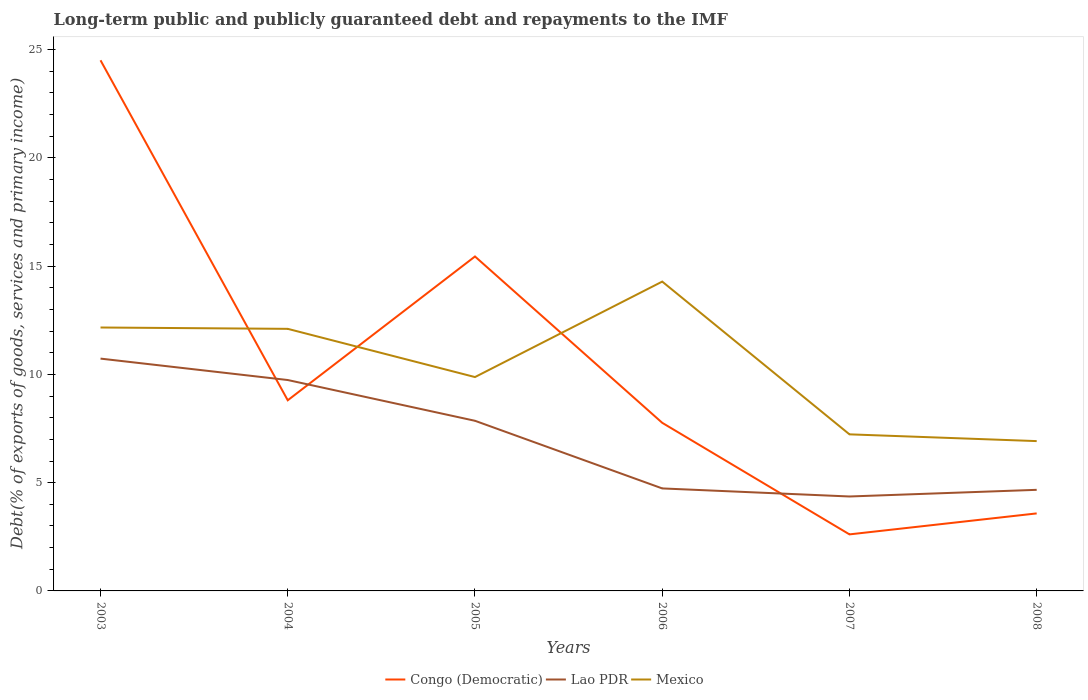Across all years, what is the maximum debt and repayments in Mexico?
Ensure brevity in your answer.  6.92. What is the total debt and repayments in Mexico in the graph?
Your answer should be compact. 5.25. What is the difference between the highest and the second highest debt and repayments in Mexico?
Your response must be concise. 7.37. Is the debt and repayments in Lao PDR strictly greater than the debt and repayments in Mexico over the years?
Ensure brevity in your answer.  Yes. How many lines are there?
Your answer should be very brief. 3. Does the graph contain grids?
Your answer should be very brief. No. How many legend labels are there?
Your answer should be compact. 3. How are the legend labels stacked?
Provide a short and direct response. Horizontal. What is the title of the graph?
Give a very brief answer. Long-term public and publicly guaranteed debt and repayments to the IMF. Does "Sudan" appear as one of the legend labels in the graph?
Offer a very short reply. No. What is the label or title of the X-axis?
Offer a very short reply. Years. What is the label or title of the Y-axis?
Give a very brief answer. Debt(% of exports of goods, services and primary income). What is the Debt(% of exports of goods, services and primary income) in Congo (Democratic) in 2003?
Keep it short and to the point. 24.51. What is the Debt(% of exports of goods, services and primary income) in Lao PDR in 2003?
Your answer should be very brief. 10.73. What is the Debt(% of exports of goods, services and primary income) in Mexico in 2003?
Offer a very short reply. 12.17. What is the Debt(% of exports of goods, services and primary income) in Congo (Democratic) in 2004?
Make the answer very short. 8.8. What is the Debt(% of exports of goods, services and primary income) in Lao PDR in 2004?
Your answer should be very brief. 9.74. What is the Debt(% of exports of goods, services and primary income) in Mexico in 2004?
Your answer should be compact. 12.1. What is the Debt(% of exports of goods, services and primary income) of Congo (Democratic) in 2005?
Make the answer very short. 15.45. What is the Debt(% of exports of goods, services and primary income) in Lao PDR in 2005?
Make the answer very short. 7.86. What is the Debt(% of exports of goods, services and primary income) in Mexico in 2005?
Offer a terse response. 9.88. What is the Debt(% of exports of goods, services and primary income) in Congo (Democratic) in 2006?
Provide a short and direct response. 7.76. What is the Debt(% of exports of goods, services and primary income) in Lao PDR in 2006?
Ensure brevity in your answer.  4.73. What is the Debt(% of exports of goods, services and primary income) of Mexico in 2006?
Make the answer very short. 14.29. What is the Debt(% of exports of goods, services and primary income) of Congo (Democratic) in 2007?
Make the answer very short. 2.61. What is the Debt(% of exports of goods, services and primary income) in Lao PDR in 2007?
Your answer should be very brief. 4.36. What is the Debt(% of exports of goods, services and primary income) of Mexico in 2007?
Offer a terse response. 7.23. What is the Debt(% of exports of goods, services and primary income) in Congo (Democratic) in 2008?
Your answer should be very brief. 3.58. What is the Debt(% of exports of goods, services and primary income) in Lao PDR in 2008?
Your answer should be compact. 4.67. What is the Debt(% of exports of goods, services and primary income) of Mexico in 2008?
Provide a short and direct response. 6.92. Across all years, what is the maximum Debt(% of exports of goods, services and primary income) of Congo (Democratic)?
Offer a very short reply. 24.51. Across all years, what is the maximum Debt(% of exports of goods, services and primary income) of Lao PDR?
Offer a terse response. 10.73. Across all years, what is the maximum Debt(% of exports of goods, services and primary income) of Mexico?
Provide a succinct answer. 14.29. Across all years, what is the minimum Debt(% of exports of goods, services and primary income) in Congo (Democratic)?
Your answer should be compact. 2.61. Across all years, what is the minimum Debt(% of exports of goods, services and primary income) of Lao PDR?
Offer a terse response. 4.36. Across all years, what is the minimum Debt(% of exports of goods, services and primary income) in Mexico?
Keep it short and to the point. 6.92. What is the total Debt(% of exports of goods, services and primary income) of Congo (Democratic) in the graph?
Give a very brief answer. 62.72. What is the total Debt(% of exports of goods, services and primary income) of Lao PDR in the graph?
Make the answer very short. 42.09. What is the total Debt(% of exports of goods, services and primary income) in Mexico in the graph?
Ensure brevity in your answer.  62.59. What is the difference between the Debt(% of exports of goods, services and primary income) of Congo (Democratic) in 2003 and that in 2004?
Give a very brief answer. 15.7. What is the difference between the Debt(% of exports of goods, services and primary income) in Mexico in 2003 and that in 2004?
Your answer should be compact. 0.06. What is the difference between the Debt(% of exports of goods, services and primary income) of Congo (Democratic) in 2003 and that in 2005?
Your answer should be compact. 9.06. What is the difference between the Debt(% of exports of goods, services and primary income) in Lao PDR in 2003 and that in 2005?
Offer a terse response. 2.87. What is the difference between the Debt(% of exports of goods, services and primary income) of Mexico in 2003 and that in 2005?
Offer a terse response. 2.29. What is the difference between the Debt(% of exports of goods, services and primary income) of Congo (Democratic) in 2003 and that in 2006?
Offer a very short reply. 16.74. What is the difference between the Debt(% of exports of goods, services and primary income) of Lao PDR in 2003 and that in 2006?
Ensure brevity in your answer.  6. What is the difference between the Debt(% of exports of goods, services and primary income) in Mexico in 2003 and that in 2006?
Make the answer very short. -2.12. What is the difference between the Debt(% of exports of goods, services and primary income) in Congo (Democratic) in 2003 and that in 2007?
Your answer should be very brief. 21.9. What is the difference between the Debt(% of exports of goods, services and primary income) in Lao PDR in 2003 and that in 2007?
Offer a very short reply. 6.37. What is the difference between the Debt(% of exports of goods, services and primary income) in Mexico in 2003 and that in 2007?
Make the answer very short. 4.93. What is the difference between the Debt(% of exports of goods, services and primary income) in Congo (Democratic) in 2003 and that in 2008?
Your response must be concise. 20.93. What is the difference between the Debt(% of exports of goods, services and primary income) in Lao PDR in 2003 and that in 2008?
Offer a very short reply. 6.06. What is the difference between the Debt(% of exports of goods, services and primary income) in Mexico in 2003 and that in 2008?
Provide a succinct answer. 5.25. What is the difference between the Debt(% of exports of goods, services and primary income) of Congo (Democratic) in 2004 and that in 2005?
Provide a short and direct response. -6.64. What is the difference between the Debt(% of exports of goods, services and primary income) of Lao PDR in 2004 and that in 2005?
Your answer should be compact. 1.88. What is the difference between the Debt(% of exports of goods, services and primary income) of Mexico in 2004 and that in 2005?
Provide a succinct answer. 2.23. What is the difference between the Debt(% of exports of goods, services and primary income) in Congo (Democratic) in 2004 and that in 2006?
Your response must be concise. 1.04. What is the difference between the Debt(% of exports of goods, services and primary income) of Lao PDR in 2004 and that in 2006?
Your response must be concise. 5.01. What is the difference between the Debt(% of exports of goods, services and primary income) in Mexico in 2004 and that in 2006?
Provide a short and direct response. -2.18. What is the difference between the Debt(% of exports of goods, services and primary income) in Congo (Democratic) in 2004 and that in 2007?
Your response must be concise. 6.19. What is the difference between the Debt(% of exports of goods, services and primary income) of Lao PDR in 2004 and that in 2007?
Your answer should be compact. 5.38. What is the difference between the Debt(% of exports of goods, services and primary income) in Mexico in 2004 and that in 2007?
Offer a terse response. 4.87. What is the difference between the Debt(% of exports of goods, services and primary income) in Congo (Democratic) in 2004 and that in 2008?
Your answer should be very brief. 5.22. What is the difference between the Debt(% of exports of goods, services and primary income) in Lao PDR in 2004 and that in 2008?
Your answer should be compact. 5.07. What is the difference between the Debt(% of exports of goods, services and primary income) in Mexico in 2004 and that in 2008?
Your answer should be very brief. 5.18. What is the difference between the Debt(% of exports of goods, services and primary income) in Congo (Democratic) in 2005 and that in 2006?
Give a very brief answer. 7.68. What is the difference between the Debt(% of exports of goods, services and primary income) of Lao PDR in 2005 and that in 2006?
Offer a very short reply. 3.12. What is the difference between the Debt(% of exports of goods, services and primary income) in Mexico in 2005 and that in 2006?
Your answer should be very brief. -4.41. What is the difference between the Debt(% of exports of goods, services and primary income) of Congo (Democratic) in 2005 and that in 2007?
Your answer should be compact. 12.84. What is the difference between the Debt(% of exports of goods, services and primary income) of Lao PDR in 2005 and that in 2007?
Keep it short and to the point. 3.5. What is the difference between the Debt(% of exports of goods, services and primary income) in Mexico in 2005 and that in 2007?
Ensure brevity in your answer.  2.65. What is the difference between the Debt(% of exports of goods, services and primary income) of Congo (Democratic) in 2005 and that in 2008?
Offer a terse response. 11.87. What is the difference between the Debt(% of exports of goods, services and primary income) of Lao PDR in 2005 and that in 2008?
Provide a short and direct response. 3.19. What is the difference between the Debt(% of exports of goods, services and primary income) of Mexico in 2005 and that in 2008?
Your response must be concise. 2.96. What is the difference between the Debt(% of exports of goods, services and primary income) in Congo (Democratic) in 2006 and that in 2007?
Your answer should be compact. 5.15. What is the difference between the Debt(% of exports of goods, services and primary income) of Lao PDR in 2006 and that in 2007?
Provide a short and direct response. 0.37. What is the difference between the Debt(% of exports of goods, services and primary income) in Mexico in 2006 and that in 2007?
Your answer should be very brief. 7.05. What is the difference between the Debt(% of exports of goods, services and primary income) of Congo (Democratic) in 2006 and that in 2008?
Your answer should be very brief. 4.18. What is the difference between the Debt(% of exports of goods, services and primary income) of Lao PDR in 2006 and that in 2008?
Your answer should be very brief. 0.07. What is the difference between the Debt(% of exports of goods, services and primary income) of Mexico in 2006 and that in 2008?
Keep it short and to the point. 7.37. What is the difference between the Debt(% of exports of goods, services and primary income) of Congo (Democratic) in 2007 and that in 2008?
Your response must be concise. -0.97. What is the difference between the Debt(% of exports of goods, services and primary income) in Lao PDR in 2007 and that in 2008?
Ensure brevity in your answer.  -0.31. What is the difference between the Debt(% of exports of goods, services and primary income) of Mexico in 2007 and that in 2008?
Provide a short and direct response. 0.31. What is the difference between the Debt(% of exports of goods, services and primary income) in Congo (Democratic) in 2003 and the Debt(% of exports of goods, services and primary income) in Lao PDR in 2004?
Offer a terse response. 14.77. What is the difference between the Debt(% of exports of goods, services and primary income) in Congo (Democratic) in 2003 and the Debt(% of exports of goods, services and primary income) in Mexico in 2004?
Offer a very short reply. 12.4. What is the difference between the Debt(% of exports of goods, services and primary income) in Lao PDR in 2003 and the Debt(% of exports of goods, services and primary income) in Mexico in 2004?
Provide a succinct answer. -1.37. What is the difference between the Debt(% of exports of goods, services and primary income) of Congo (Democratic) in 2003 and the Debt(% of exports of goods, services and primary income) of Lao PDR in 2005?
Your answer should be very brief. 16.65. What is the difference between the Debt(% of exports of goods, services and primary income) of Congo (Democratic) in 2003 and the Debt(% of exports of goods, services and primary income) of Mexico in 2005?
Provide a succinct answer. 14.63. What is the difference between the Debt(% of exports of goods, services and primary income) in Lao PDR in 2003 and the Debt(% of exports of goods, services and primary income) in Mexico in 2005?
Give a very brief answer. 0.85. What is the difference between the Debt(% of exports of goods, services and primary income) of Congo (Democratic) in 2003 and the Debt(% of exports of goods, services and primary income) of Lao PDR in 2006?
Ensure brevity in your answer.  19.77. What is the difference between the Debt(% of exports of goods, services and primary income) in Congo (Democratic) in 2003 and the Debt(% of exports of goods, services and primary income) in Mexico in 2006?
Give a very brief answer. 10.22. What is the difference between the Debt(% of exports of goods, services and primary income) of Lao PDR in 2003 and the Debt(% of exports of goods, services and primary income) of Mexico in 2006?
Ensure brevity in your answer.  -3.56. What is the difference between the Debt(% of exports of goods, services and primary income) of Congo (Democratic) in 2003 and the Debt(% of exports of goods, services and primary income) of Lao PDR in 2007?
Provide a succinct answer. 20.15. What is the difference between the Debt(% of exports of goods, services and primary income) in Congo (Democratic) in 2003 and the Debt(% of exports of goods, services and primary income) in Mexico in 2007?
Give a very brief answer. 17.28. What is the difference between the Debt(% of exports of goods, services and primary income) of Lao PDR in 2003 and the Debt(% of exports of goods, services and primary income) of Mexico in 2007?
Your answer should be very brief. 3.5. What is the difference between the Debt(% of exports of goods, services and primary income) in Congo (Democratic) in 2003 and the Debt(% of exports of goods, services and primary income) in Lao PDR in 2008?
Provide a succinct answer. 19.84. What is the difference between the Debt(% of exports of goods, services and primary income) in Congo (Democratic) in 2003 and the Debt(% of exports of goods, services and primary income) in Mexico in 2008?
Your answer should be very brief. 17.59. What is the difference between the Debt(% of exports of goods, services and primary income) in Lao PDR in 2003 and the Debt(% of exports of goods, services and primary income) in Mexico in 2008?
Give a very brief answer. 3.81. What is the difference between the Debt(% of exports of goods, services and primary income) of Congo (Democratic) in 2004 and the Debt(% of exports of goods, services and primary income) of Lao PDR in 2005?
Offer a terse response. 0.95. What is the difference between the Debt(% of exports of goods, services and primary income) of Congo (Democratic) in 2004 and the Debt(% of exports of goods, services and primary income) of Mexico in 2005?
Your answer should be compact. -1.07. What is the difference between the Debt(% of exports of goods, services and primary income) of Lao PDR in 2004 and the Debt(% of exports of goods, services and primary income) of Mexico in 2005?
Offer a terse response. -0.14. What is the difference between the Debt(% of exports of goods, services and primary income) in Congo (Democratic) in 2004 and the Debt(% of exports of goods, services and primary income) in Lao PDR in 2006?
Provide a short and direct response. 4.07. What is the difference between the Debt(% of exports of goods, services and primary income) of Congo (Democratic) in 2004 and the Debt(% of exports of goods, services and primary income) of Mexico in 2006?
Offer a terse response. -5.48. What is the difference between the Debt(% of exports of goods, services and primary income) in Lao PDR in 2004 and the Debt(% of exports of goods, services and primary income) in Mexico in 2006?
Your answer should be very brief. -4.55. What is the difference between the Debt(% of exports of goods, services and primary income) of Congo (Democratic) in 2004 and the Debt(% of exports of goods, services and primary income) of Lao PDR in 2007?
Offer a very short reply. 4.44. What is the difference between the Debt(% of exports of goods, services and primary income) of Congo (Democratic) in 2004 and the Debt(% of exports of goods, services and primary income) of Mexico in 2007?
Make the answer very short. 1.57. What is the difference between the Debt(% of exports of goods, services and primary income) in Lao PDR in 2004 and the Debt(% of exports of goods, services and primary income) in Mexico in 2007?
Provide a succinct answer. 2.51. What is the difference between the Debt(% of exports of goods, services and primary income) in Congo (Democratic) in 2004 and the Debt(% of exports of goods, services and primary income) in Lao PDR in 2008?
Keep it short and to the point. 4.14. What is the difference between the Debt(% of exports of goods, services and primary income) of Congo (Democratic) in 2004 and the Debt(% of exports of goods, services and primary income) of Mexico in 2008?
Your answer should be compact. 1.89. What is the difference between the Debt(% of exports of goods, services and primary income) of Lao PDR in 2004 and the Debt(% of exports of goods, services and primary income) of Mexico in 2008?
Provide a short and direct response. 2.82. What is the difference between the Debt(% of exports of goods, services and primary income) of Congo (Democratic) in 2005 and the Debt(% of exports of goods, services and primary income) of Lao PDR in 2006?
Your answer should be compact. 10.71. What is the difference between the Debt(% of exports of goods, services and primary income) in Congo (Democratic) in 2005 and the Debt(% of exports of goods, services and primary income) in Mexico in 2006?
Provide a short and direct response. 1.16. What is the difference between the Debt(% of exports of goods, services and primary income) in Lao PDR in 2005 and the Debt(% of exports of goods, services and primary income) in Mexico in 2006?
Your answer should be very brief. -6.43. What is the difference between the Debt(% of exports of goods, services and primary income) of Congo (Democratic) in 2005 and the Debt(% of exports of goods, services and primary income) of Lao PDR in 2007?
Offer a terse response. 11.08. What is the difference between the Debt(% of exports of goods, services and primary income) of Congo (Democratic) in 2005 and the Debt(% of exports of goods, services and primary income) of Mexico in 2007?
Your answer should be very brief. 8.21. What is the difference between the Debt(% of exports of goods, services and primary income) in Lao PDR in 2005 and the Debt(% of exports of goods, services and primary income) in Mexico in 2007?
Ensure brevity in your answer.  0.63. What is the difference between the Debt(% of exports of goods, services and primary income) in Congo (Democratic) in 2005 and the Debt(% of exports of goods, services and primary income) in Lao PDR in 2008?
Offer a terse response. 10.78. What is the difference between the Debt(% of exports of goods, services and primary income) in Congo (Democratic) in 2005 and the Debt(% of exports of goods, services and primary income) in Mexico in 2008?
Give a very brief answer. 8.53. What is the difference between the Debt(% of exports of goods, services and primary income) of Lao PDR in 2005 and the Debt(% of exports of goods, services and primary income) of Mexico in 2008?
Your response must be concise. 0.94. What is the difference between the Debt(% of exports of goods, services and primary income) in Congo (Democratic) in 2006 and the Debt(% of exports of goods, services and primary income) in Lao PDR in 2007?
Your answer should be very brief. 3.4. What is the difference between the Debt(% of exports of goods, services and primary income) of Congo (Democratic) in 2006 and the Debt(% of exports of goods, services and primary income) of Mexico in 2007?
Your answer should be very brief. 0.53. What is the difference between the Debt(% of exports of goods, services and primary income) in Lao PDR in 2006 and the Debt(% of exports of goods, services and primary income) in Mexico in 2007?
Make the answer very short. -2.5. What is the difference between the Debt(% of exports of goods, services and primary income) in Congo (Democratic) in 2006 and the Debt(% of exports of goods, services and primary income) in Lao PDR in 2008?
Offer a very short reply. 3.1. What is the difference between the Debt(% of exports of goods, services and primary income) in Congo (Democratic) in 2006 and the Debt(% of exports of goods, services and primary income) in Mexico in 2008?
Your answer should be very brief. 0.84. What is the difference between the Debt(% of exports of goods, services and primary income) in Lao PDR in 2006 and the Debt(% of exports of goods, services and primary income) in Mexico in 2008?
Offer a very short reply. -2.19. What is the difference between the Debt(% of exports of goods, services and primary income) of Congo (Democratic) in 2007 and the Debt(% of exports of goods, services and primary income) of Lao PDR in 2008?
Provide a succinct answer. -2.06. What is the difference between the Debt(% of exports of goods, services and primary income) in Congo (Democratic) in 2007 and the Debt(% of exports of goods, services and primary income) in Mexico in 2008?
Your response must be concise. -4.31. What is the difference between the Debt(% of exports of goods, services and primary income) of Lao PDR in 2007 and the Debt(% of exports of goods, services and primary income) of Mexico in 2008?
Give a very brief answer. -2.56. What is the average Debt(% of exports of goods, services and primary income) in Congo (Democratic) per year?
Give a very brief answer. 10.45. What is the average Debt(% of exports of goods, services and primary income) in Lao PDR per year?
Your answer should be very brief. 7.02. What is the average Debt(% of exports of goods, services and primary income) of Mexico per year?
Your answer should be compact. 10.43. In the year 2003, what is the difference between the Debt(% of exports of goods, services and primary income) in Congo (Democratic) and Debt(% of exports of goods, services and primary income) in Lao PDR?
Your answer should be compact. 13.78. In the year 2003, what is the difference between the Debt(% of exports of goods, services and primary income) of Congo (Democratic) and Debt(% of exports of goods, services and primary income) of Mexico?
Your answer should be compact. 12.34. In the year 2003, what is the difference between the Debt(% of exports of goods, services and primary income) of Lao PDR and Debt(% of exports of goods, services and primary income) of Mexico?
Offer a terse response. -1.44. In the year 2004, what is the difference between the Debt(% of exports of goods, services and primary income) in Congo (Democratic) and Debt(% of exports of goods, services and primary income) in Lao PDR?
Your answer should be compact. -0.94. In the year 2004, what is the difference between the Debt(% of exports of goods, services and primary income) in Congo (Democratic) and Debt(% of exports of goods, services and primary income) in Mexico?
Ensure brevity in your answer.  -3.3. In the year 2004, what is the difference between the Debt(% of exports of goods, services and primary income) of Lao PDR and Debt(% of exports of goods, services and primary income) of Mexico?
Give a very brief answer. -2.36. In the year 2005, what is the difference between the Debt(% of exports of goods, services and primary income) of Congo (Democratic) and Debt(% of exports of goods, services and primary income) of Lao PDR?
Offer a terse response. 7.59. In the year 2005, what is the difference between the Debt(% of exports of goods, services and primary income) of Congo (Democratic) and Debt(% of exports of goods, services and primary income) of Mexico?
Keep it short and to the point. 5.57. In the year 2005, what is the difference between the Debt(% of exports of goods, services and primary income) of Lao PDR and Debt(% of exports of goods, services and primary income) of Mexico?
Your response must be concise. -2.02. In the year 2006, what is the difference between the Debt(% of exports of goods, services and primary income) in Congo (Democratic) and Debt(% of exports of goods, services and primary income) in Lao PDR?
Your response must be concise. 3.03. In the year 2006, what is the difference between the Debt(% of exports of goods, services and primary income) in Congo (Democratic) and Debt(% of exports of goods, services and primary income) in Mexico?
Ensure brevity in your answer.  -6.52. In the year 2006, what is the difference between the Debt(% of exports of goods, services and primary income) in Lao PDR and Debt(% of exports of goods, services and primary income) in Mexico?
Your response must be concise. -9.55. In the year 2007, what is the difference between the Debt(% of exports of goods, services and primary income) of Congo (Democratic) and Debt(% of exports of goods, services and primary income) of Lao PDR?
Provide a short and direct response. -1.75. In the year 2007, what is the difference between the Debt(% of exports of goods, services and primary income) in Congo (Democratic) and Debt(% of exports of goods, services and primary income) in Mexico?
Keep it short and to the point. -4.62. In the year 2007, what is the difference between the Debt(% of exports of goods, services and primary income) of Lao PDR and Debt(% of exports of goods, services and primary income) of Mexico?
Give a very brief answer. -2.87. In the year 2008, what is the difference between the Debt(% of exports of goods, services and primary income) in Congo (Democratic) and Debt(% of exports of goods, services and primary income) in Lao PDR?
Offer a terse response. -1.09. In the year 2008, what is the difference between the Debt(% of exports of goods, services and primary income) of Congo (Democratic) and Debt(% of exports of goods, services and primary income) of Mexico?
Offer a terse response. -3.34. In the year 2008, what is the difference between the Debt(% of exports of goods, services and primary income) in Lao PDR and Debt(% of exports of goods, services and primary income) in Mexico?
Keep it short and to the point. -2.25. What is the ratio of the Debt(% of exports of goods, services and primary income) in Congo (Democratic) in 2003 to that in 2004?
Your answer should be compact. 2.78. What is the ratio of the Debt(% of exports of goods, services and primary income) in Lao PDR in 2003 to that in 2004?
Make the answer very short. 1.1. What is the ratio of the Debt(% of exports of goods, services and primary income) in Mexico in 2003 to that in 2004?
Give a very brief answer. 1.01. What is the ratio of the Debt(% of exports of goods, services and primary income) of Congo (Democratic) in 2003 to that in 2005?
Your answer should be compact. 1.59. What is the ratio of the Debt(% of exports of goods, services and primary income) of Lao PDR in 2003 to that in 2005?
Ensure brevity in your answer.  1.37. What is the ratio of the Debt(% of exports of goods, services and primary income) of Mexico in 2003 to that in 2005?
Ensure brevity in your answer.  1.23. What is the ratio of the Debt(% of exports of goods, services and primary income) in Congo (Democratic) in 2003 to that in 2006?
Offer a very short reply. 3.16. What is the ratio of the Debt(% of exports of goods, services and primary income) of Lao PDR in 2003 to that in 2006?
Offer a very short reply. 2.27. What is the ratio of the Debt(% of exports of goods, services and primary income) of Mexico in 2003 to that in 2006?
Make the answer very short. 0.85. What is the ratio of the Debt(% of exports of goods, services and primary income) in Congo (Democratic) in 2003 to that in 2007?
Ensure brevity in your answer.  9.38. What is the ratio of the Debt(% of exports of goods, services and primary income) of Lao PDR in 2003 to that in 2007?
Offer a very short reply. 2.46. What is the ratio of the Debt(% of exports of goods, services and primary income) of Mexico in 2003 to that in 2007?
Keep it short and to the point. 1.68. What is the ratio of the Debt(% of exports of goods, services and primary income) in Congo (Democratic) in 2003 to that in 2008?
Offer a very short reply. 6.85. What is the ratio of the Debt(% of exports of goods, services and primary income) in Lao PDR in 2003 to that in 2008?
Make the answer very short. 2.3. What is the ratio of the Debt(% of exports of goods, services and primary income) in Mexico in 2003 to that in 2008?
Provide a succinct answer. 1.76. What is the ratio of the Debt(% of exports of goods, services and primary income) of Congo (Democratic) in 2004 to that in 2005?
Your response must be concise. 0.57. What is the ratio of the Debt(% of exports of goods, services and primary income) in Lao PDR in 2004 to that in 2005?
Your response must be concise. 1.24. What is the ratio of the Debt(% of exports of goods, services and primary income) in Mexico in 2004 to that in 2005?
Ensure brevity in your answer.  1.23. What is the ratio of the Debt(% of exports of goods, services and primary income) in Congo (Democratic) in 2004 to that in 2006?
Keep it short and to the point. 1.13. What is the ratio of the Debt(% of exports of goods, services and primary income) in Lao PDR in 2004 to that in 2006?
Your answer should be very brief. 2.06. What is the ratio of the Debt(% of exports of goods, services and primary income) of Mexico in 2004 to that in 2006?
Give a very brief answer. 0.85. What is the ratio of the Debt(% of exports of goods, services and primary income) of Congo (Democratic) in 2004 to that in 2007?
Give a very brief answer. 3.37. What is the ratio of the Debt(% of exports of goods, services and primary income) in Lao PDR in 2004 to that in 2007?
Your response must be concise. 2.23. What is the ratio of the Debt(% of exports of goods, services and primary income) in Mexico in 2004 to that in 2007?
Offer a very short reply. 1.67. What is the ratio of the Debt(% of exports of goods, services and primary income) in Congo (Democratic) in 2004 to that in 2008?
Your answer should be compact. 2.46. What is the ratio of the Debt(% of exports of goods, services and primary income) in Lao PDR in 2004 to that in 2008?
Offer a terse response. 2.09. What is the ratio of the Debt(% of exports of goods, services and primary income) of Mexico in 2004 to that in 2008?
Your answer should be very brief. 1.75. What is the ratio of the Debt(% of exports of goods, services and primary income) in Congo (Democratic) in 2005 to that in 2006?
Ensure brevity in your answer.  1.99. What is the ratio of the Debt(% of exports of goods, services and primary income) in Lao PDR in 2005 to that in 2006?
Keep it short and to the point. 1.66. What is the ratio of the Debt(% of exports of goods, services and primary income) of Mexico in 2005 to that in 2006?
Keep it short and to the point. 0.69. What is the ratio of the Debt(% of exports of goods, services and primary income) of Congo (Democratic) in 2005 to that in 2007?
Give a very brief answer. 5.91. What is the ratio of the Debt(% of exports of goods, services and primary income) of Lao PDR in 2005 to that in 2007?
Give a very brief answer. 1.8. What is the ratio of the Debt(% of exports of goods, services and primary income) of Mexico in 2005 to that in 2007?
Your answer should be compact. 1.37. What is the ratio of the Debt(% of exports of goods, services and primary income) in Congo (Democratic) in 2005 to that in 2008?
Make the answer very short. 4.31. What is the ratio of the Debt(% of exports of goods, services and primary income) in Lao PDR in 2005 to that in 2008?
Offer a very short reply. 1.68. What is the ratio of the Debt(% of exports of goods, services and primary income) in Mexico in 2005 to that in 2008?
Provide a short and direct response. 1.43. What is the ratio of the Debt(% of exports of goods, services and primary income) in Congo (Democratic) in 2006 to that in 2007?
Make the answer very short. 2.97. What is the ratio of the Debt(% of exports of goods, services and primary income) in Lao PDR in 2006 to that in 2007?
Provide a short and direct response. 1.09. What is the ratio of the Debt(% of exports of goods, services and primary income) of Mexico in 2006 to that in 2007?
Make the answer very short. 1.98. What is the ratio of the Debt(% of exports of goods, services and primary income) in Congo (Democratic) in 2006 to that in 2008?
Give a very brief answer. 2.17. What is the ratio of the Debt(% of exports of goods, services and primary income) in Lao PDR in 2006 to that in 2008?
Your answer should be very brief. 1.01. What is the ratio of the Debt(% of exports of goods, services and primary income) in Mexico in 2006 to that in 2008?
Provide a short and direct response. 2.06. What is the ratio of the Debt(% of exports of goods, services and primary income) in Congo (Democratic) in 2007 to that in 2008?
Your response must be concise. 0.73. What is the ratio of the Debt(% of exports of goods, services and primary income) in Lao PDR in 2007 to that in 2008?
Offer a terse response. 0.93. What is the ratio of the Debt(% of exports of goods, services and primary income) in Mexico in 2007 to that in 2008?
Provide a short and direct response. 1.05. What is the difference between the highest and the second highest Debt(% of exports of goods, services and primary income) of Congo (Democratic)?
Provide a short and direct response. 9.06. What is the difference between the highest and the second highest Debt(% of exports of goods, services and primary income) of Lao PDR?
Keep it short and to the point. 0.99. What is the difference between the highest and the second highest Debt(% of exports of goods, services and primary income) of Mexico?
Your response must be concise. 2.12. What is the difference between the highest and the lowest Debt(% of exports of goods, services and primary income) in Congo (Democratic)?
Provide a succinct answer. 21.9. What is the difference between the highest and the lowest Debt(% of exports of goods, services and primary income) in Lao PDR?
Provide a short and direct response. 6.37. What is the difference between the highest and the lowest Debt(% of exports of goods, services and primary income) of Mexico?
Make the answer very short. 7.37. 